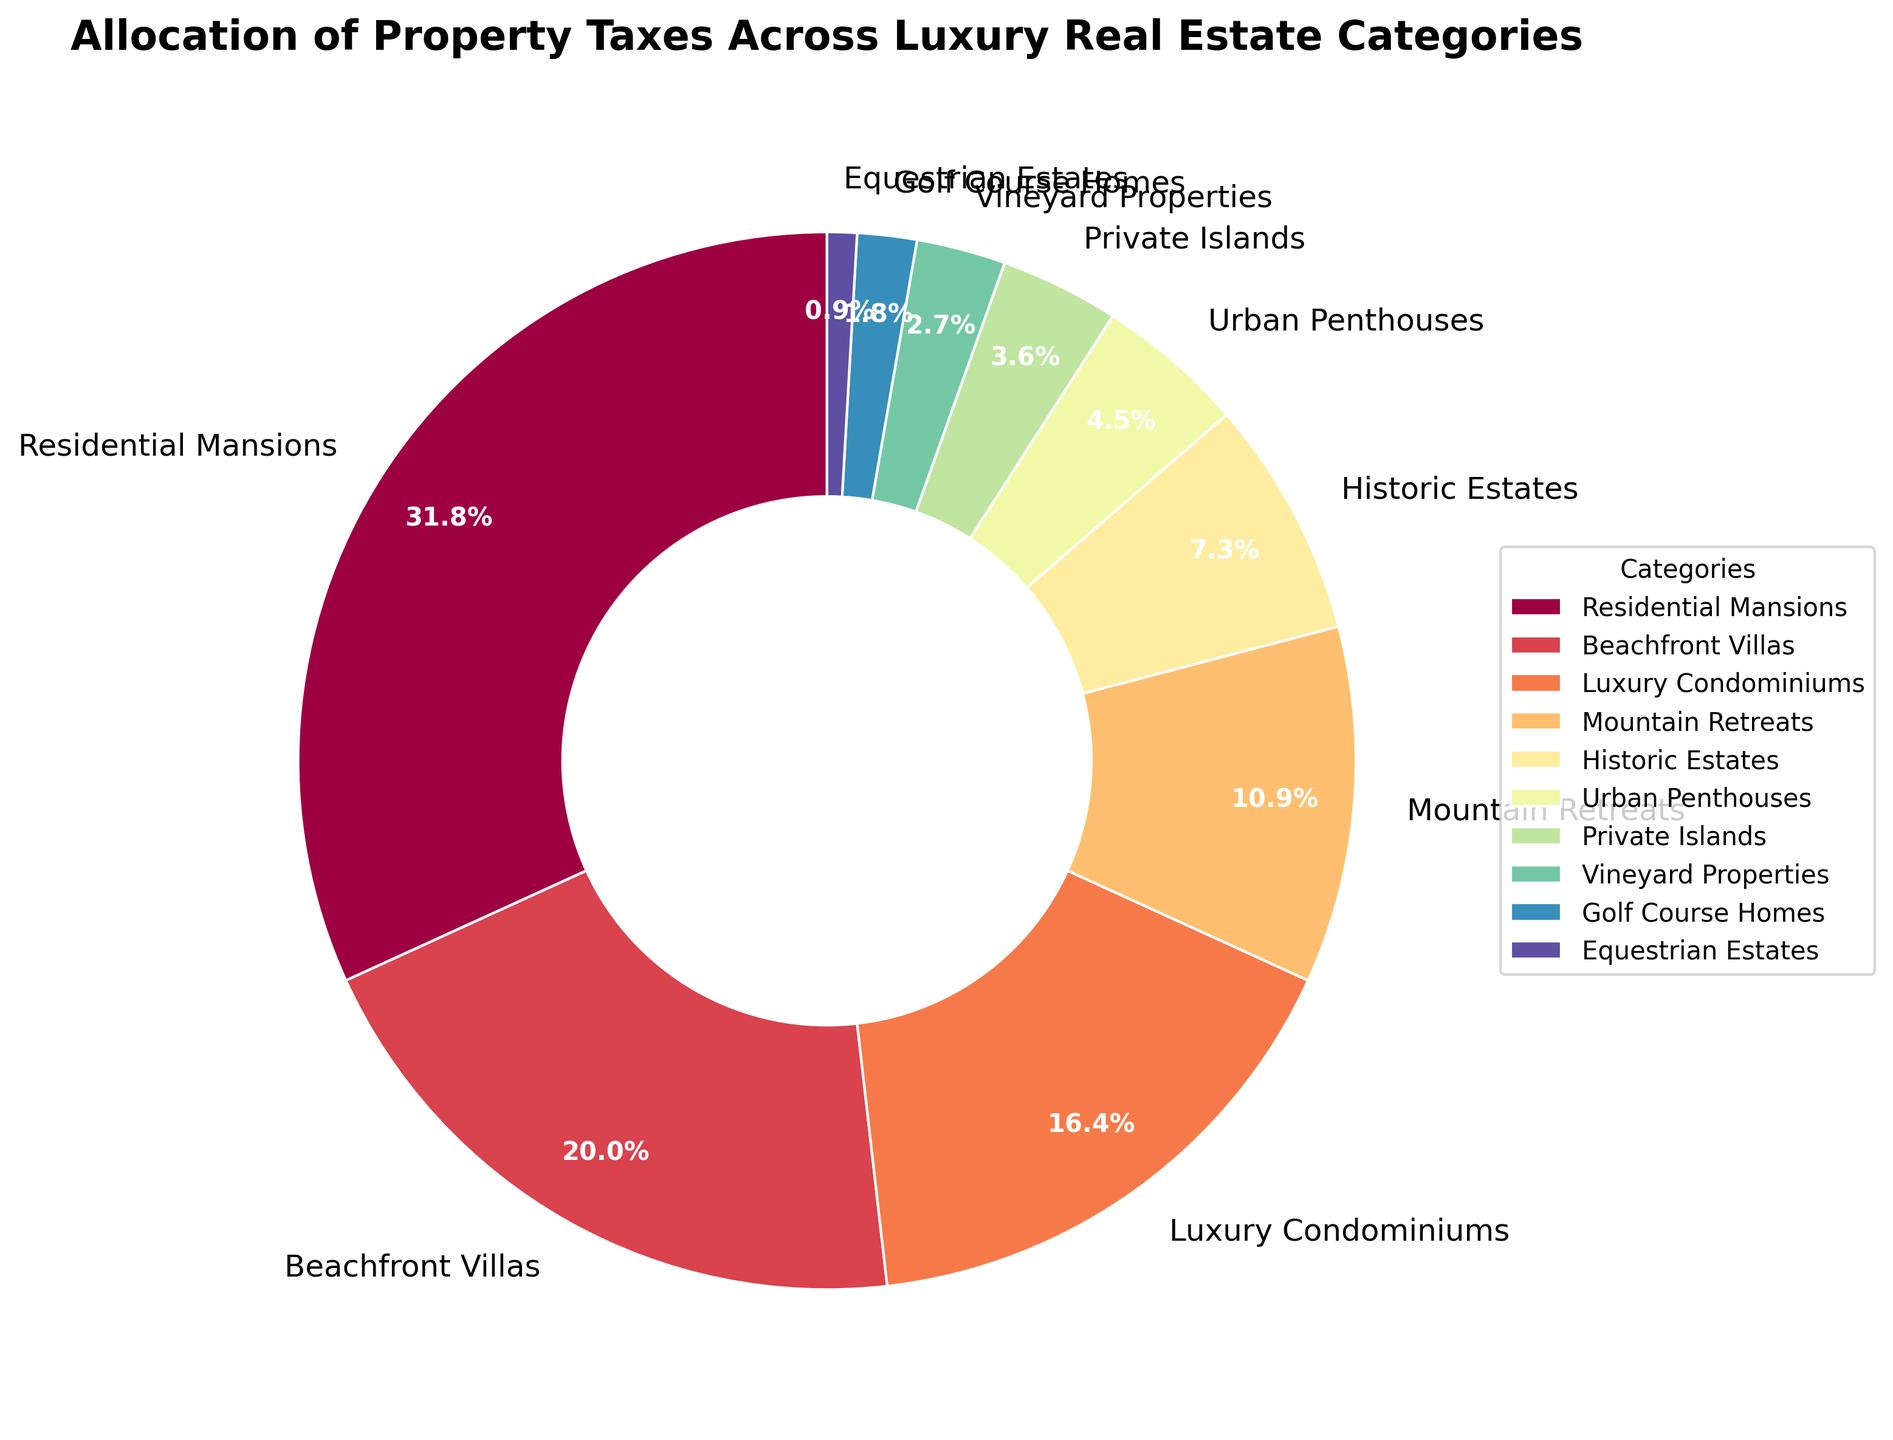Which category has the highest allocation of property taxes? The category with the highest percentage slice in the pie chart represents the highest allocation of property taxes. In this case, "Residential Mansions" occupy the largest section.
Answer: Residential Mansions How much more in percentage does the 'Residential Mansions' category have compared to 'Beachfront Villas'? To find this, subtract the percentage of 'Beachfront Villas' (22%) from 'Residential Mansions' (35%). 35% - 22% = 13%.
Answer: 13% What is the combined percentage of 'Mountain Retreats' and 'Historic Estates'? Add the percentages of 'Mountain Retreats' (12%) and 'Historic Estates' (8%). 12% + 8% = 20%.
Answer: 20% Which categories have less than 5% allocation of property taxes? The breakdown of the slices will show categories with less than 5%. 'Private Islands', 'Vineyard Properties', 'Golf Course Homes', and 'Equestrian Estates' each have allocations less than 5%.
Answer: Private Islands, Vineyard Properties, Golf Course Homes, Equestrian Estates What is the cumulative percentage of the categories that each have an allocation of 10% or more? Add the percentages of 'Residential Mansions' (35%), 'Beachfront Villas' (22%), and 'Luxury Condominiums' (18%). 35% + 22% + 18% = 75%.
Answer: 75% What is the difference in percentage between 'Urban Penthouses' and 'Equestrian Estates'? Subtract the smaller category 'Equestrian Estates' (1%) from the larger 'Urban Penthouses' (5%). 5% - 1% = 4%.
Answer: 4% Rank the categories in decreasing order of their property tax allocation. Look at each slice size and order the categories accordingly: 'Residential Mansions', 'Beachfront Villas', 'Luxury Condominiums', 'Mountain Retreats', 'Historic Estates', 'Urban Penthouses', 'Private Islands', 'Vineyard Properties', 'Golf Course Homes', 'Equestrian Estates'.
Answer: Residential Mansions, Beachfront Villas, Luxury Condominiums, Mountain Retreats, Historic Estates, Urban Penthouses, Private Islands, Vineyard Properties, Golf Course Homes, Equestrian Estates What fraction of the total property tax allocation do 'Beachfront Villas', 'Luxury Condominiums', and 'Private Islands' represent together? Convert their combined percentage to a fraction. (22% + 18% + 4% = 44%). The fraction is 44/100.
Answer: 44/100 Describe the color distribution for 'Historic Estates' and 'Luxury Condominiums'. The specific slices labeled 'Historic Estates' and 'Luxury Condominiums' will each have unique colors based on the defined colormap (speaking visually from the pie chart, without coding specifics).
Answer: Inspect the chart for unique colors 